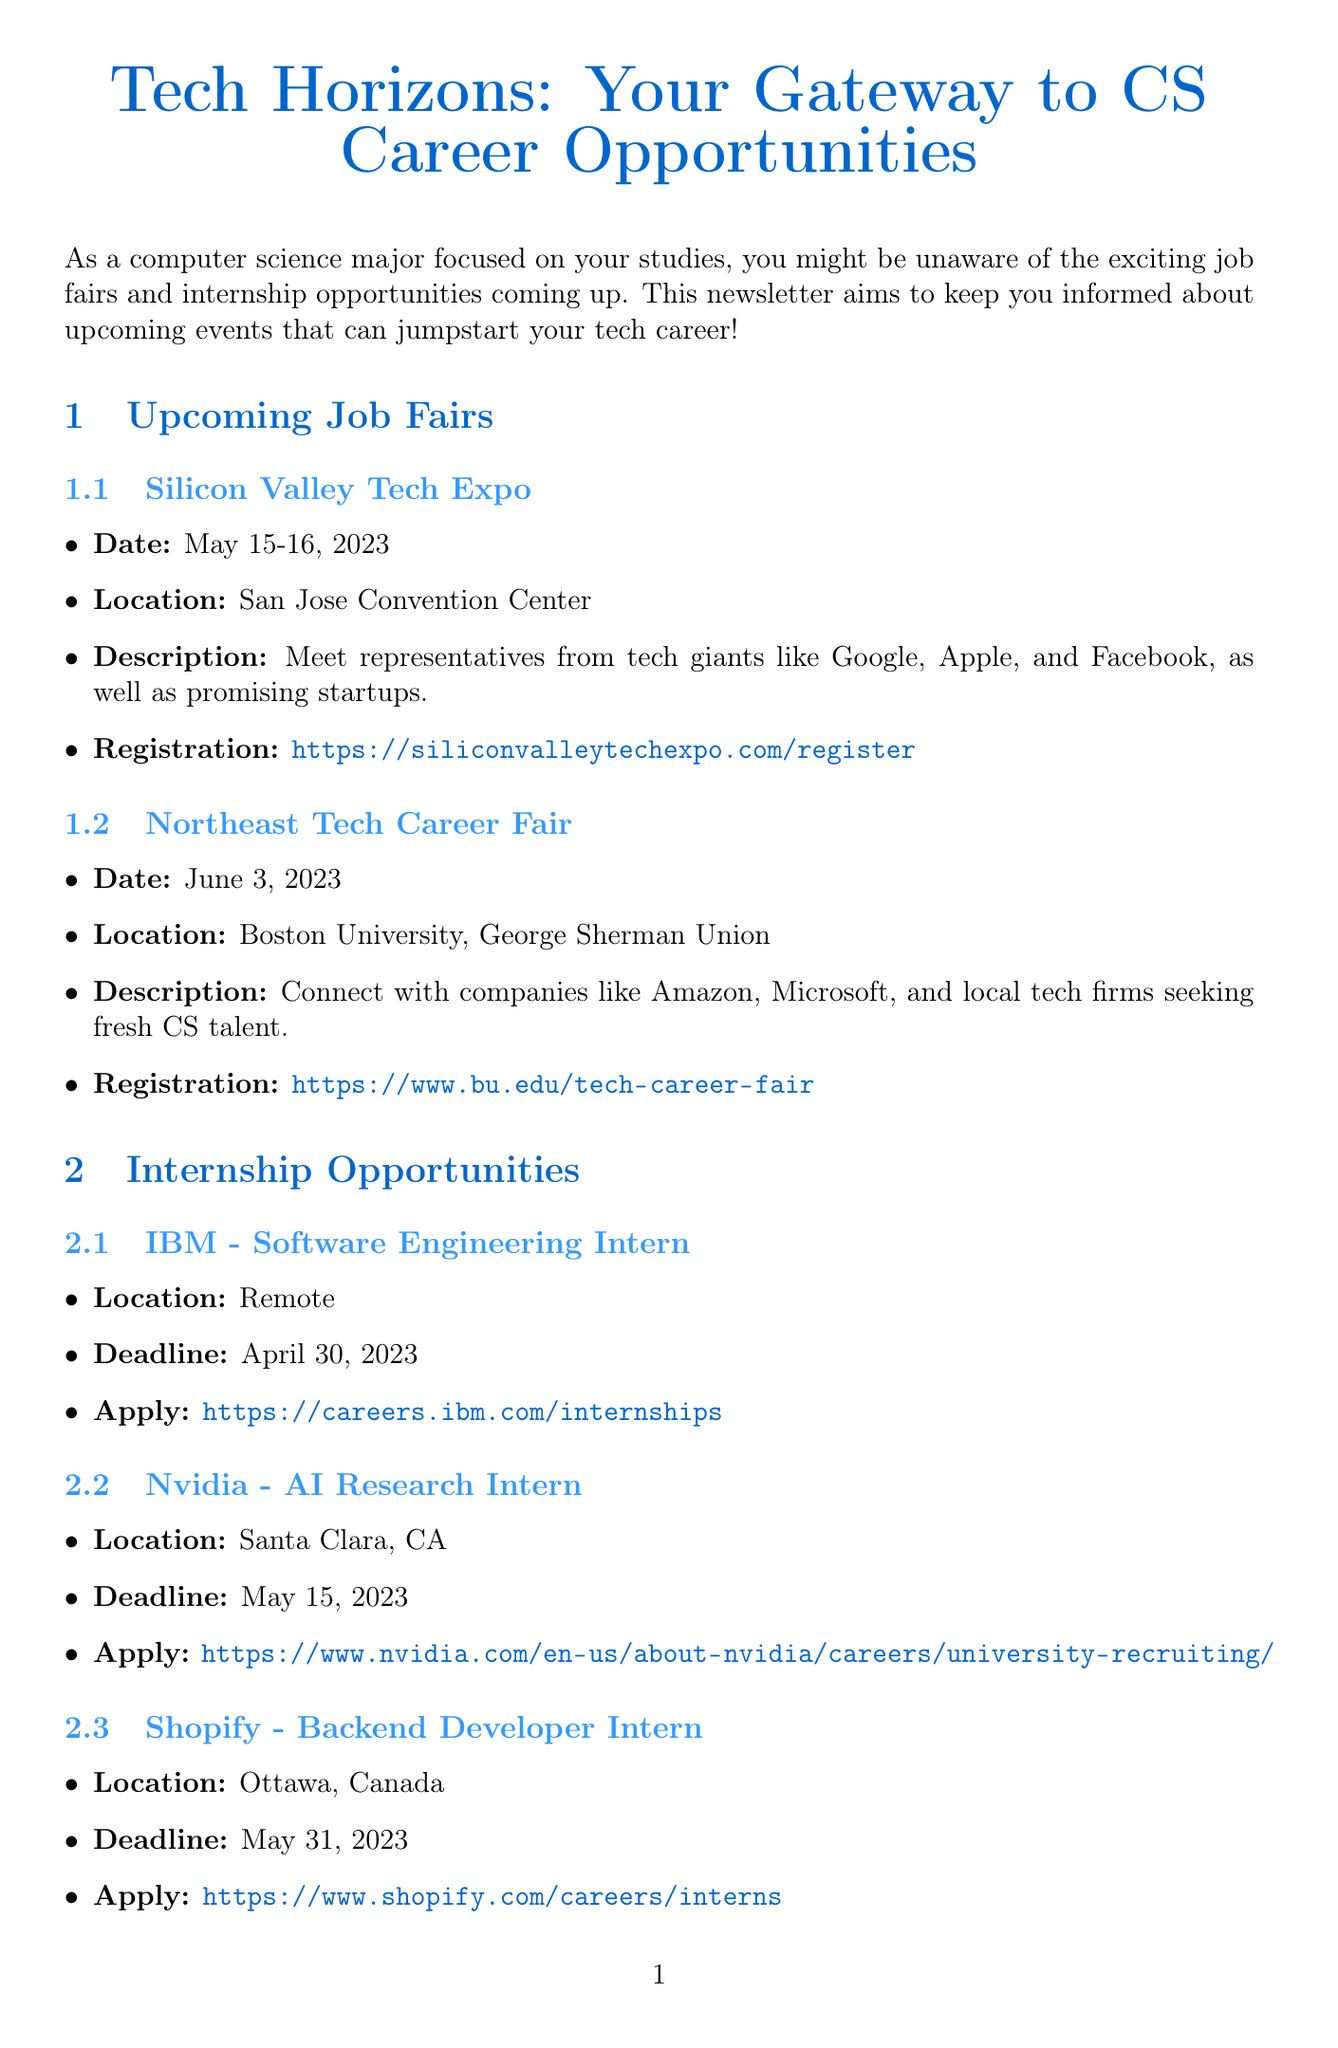What is the title of the newsletter? The title of the newsletter is presented clearly at the top of the document.
Answer: Tech Horizons: Your Gateway to CS Career Opportunities When is the Silicon Valley Tech Expo? The date for the Silicon Valley Tech Expo is provided in the upcoming job fairs section.
Answer: May 15-16, 2023 Where is the Northeast Tech Career Fair taking place? The location of the Northeast Tech Career Fair is specified in the job fairs section of the document.
Answer: Boston University, George Sherman Union What position is Nvidia offering for an internship? The specific internship position available at Nvidia is mentioned in the internship opportunities section.
Answer: AI Research Intern What is the application deadline for the Shopify internship? The document specifies the deadline for applying to the Shopify internship.
Answer: May 31, 2023 What type of workshop is being offered on April 22, 2023? The type of workshop is clearly stated in the resume workshop section of the newsletter.
Answer: Resume Workshop What resource can be used to practice coding problems for interviews? One of the resources listed for interview preparation is aimed at practicing coding problems.
Answer: LeetCode Which book is suggested for preparing for technical interviews? The document mentions a specific book that is a must-read for interview preparation.
Answer: Cracking the Coding Interview What is the main goal of this newsletter? The introduction explains the primary purpose of the newsletter.
Answer: To keep you informed about upcoming events that can jumpstart your tech career! 